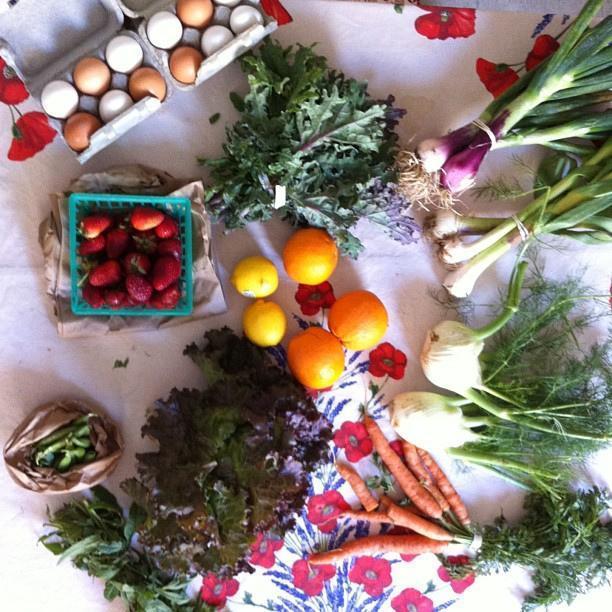How many oranges are in the picture?
Give a very brief answer. 4. How many ski poles does this person have?
Give a very brief answer. 0. 